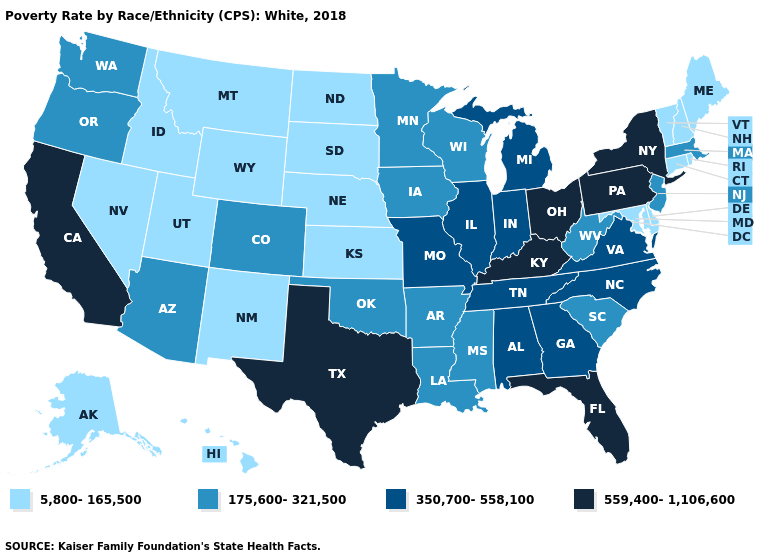Does Louisiana have the highest value in the South?
Answer briefly. No. Name the states that have a value in the range 350,700-558,100?
Keep it brief. Alabama, Georgia, Illinois, Indiana, Michigan, Missouri, North Carolina, Tennessee, Virginia. What is the value of Arkansas?
Be succinct. 175,600-321,500. What is the value of Iowa?
Be succinct. 175,600-321,500. Among the states that border Idaho , does Montana have the highest value?
Be succinct. No. Does Kansas have the lowest value in the USA?
Write a very short answer. Yes. What is the lowest value in the MidWest?
Quick response, please. 5,800-165,500. Which states have the lowest value in the Northeast?
Quick response, please. Connecticut, Maine, New Hampshire, Rhode Island, Vermont. What is the value of Wyoming?
Concise answer only. 5,800-165,500. Name the states that have a value in the range 350,700-558,100?
Be succinct. Alabama, Georgia, Illinois, Indiana, Michigan, Missouri, North Carolina, Tennessee, Virginia. Name the states that have a value in the range 350,700-558,100?
Write a very short answer. Alabama, Georgia, Illinois, Indiana, Michigan, Missouri, North Carolina, Tennessee, Virginia. Name the states that have a value in the range 559,400-1,106,600?
Write a very short answer. California, Florida, Kentucky, New York, Ohio, Pennsylvania, Texas. Does the map have missing data?
Short answer required. No. Name the states that have a value in the range 5,800-165,500?
Give a very brief answer. Alaska, Connecticut, Delaware, Hawaii, Idaho, Kansas, Maine, Maryland, Montana, Nebraska, Nevada, New Hampshire, New Mexico, North Dakota, Rhode Island, South Dakota, Utah, Vermont, Wyoming. Among the states that border Iowa , does Illinois have the highest value?
Quick response, please. Yes. 